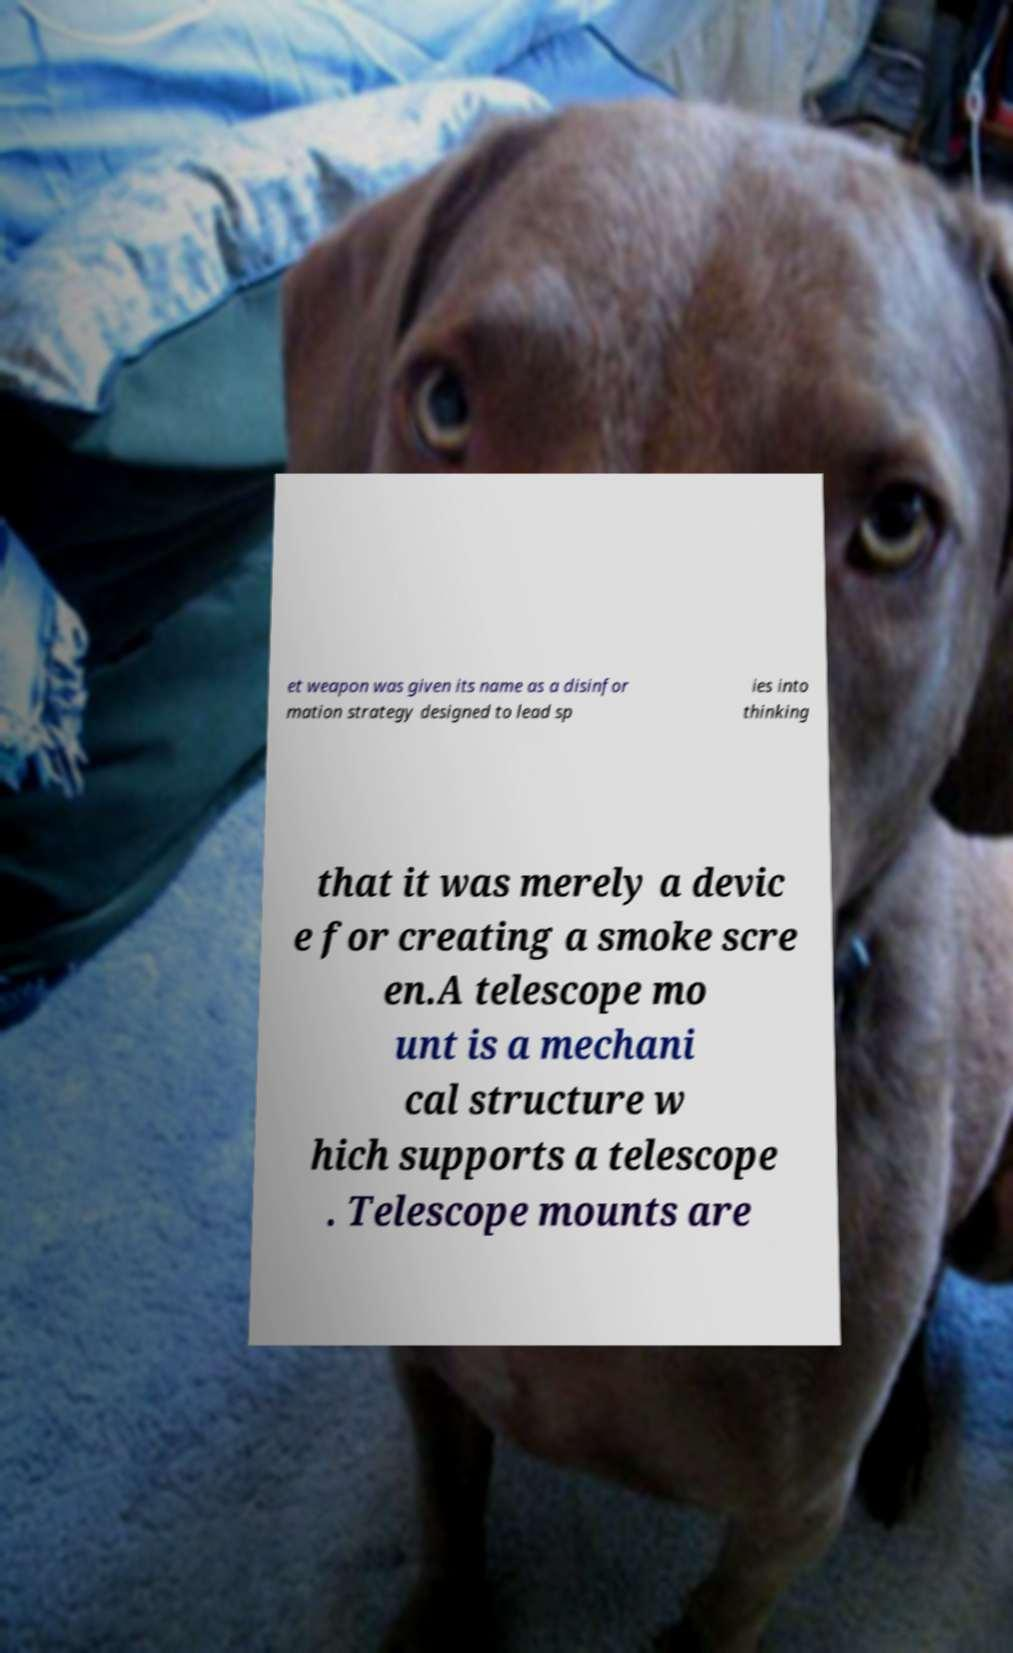For documentation purposes, I need the text within this image transcribed. Could you provide that? et weapon was given its name as a disinfor mation strategy designed to lead sp ies into thinking that it was merely a devic e for creating a smoke scre en.A telescope mo unt is a mechani cal structure w hich supports a telescope . Telescope mounts are 